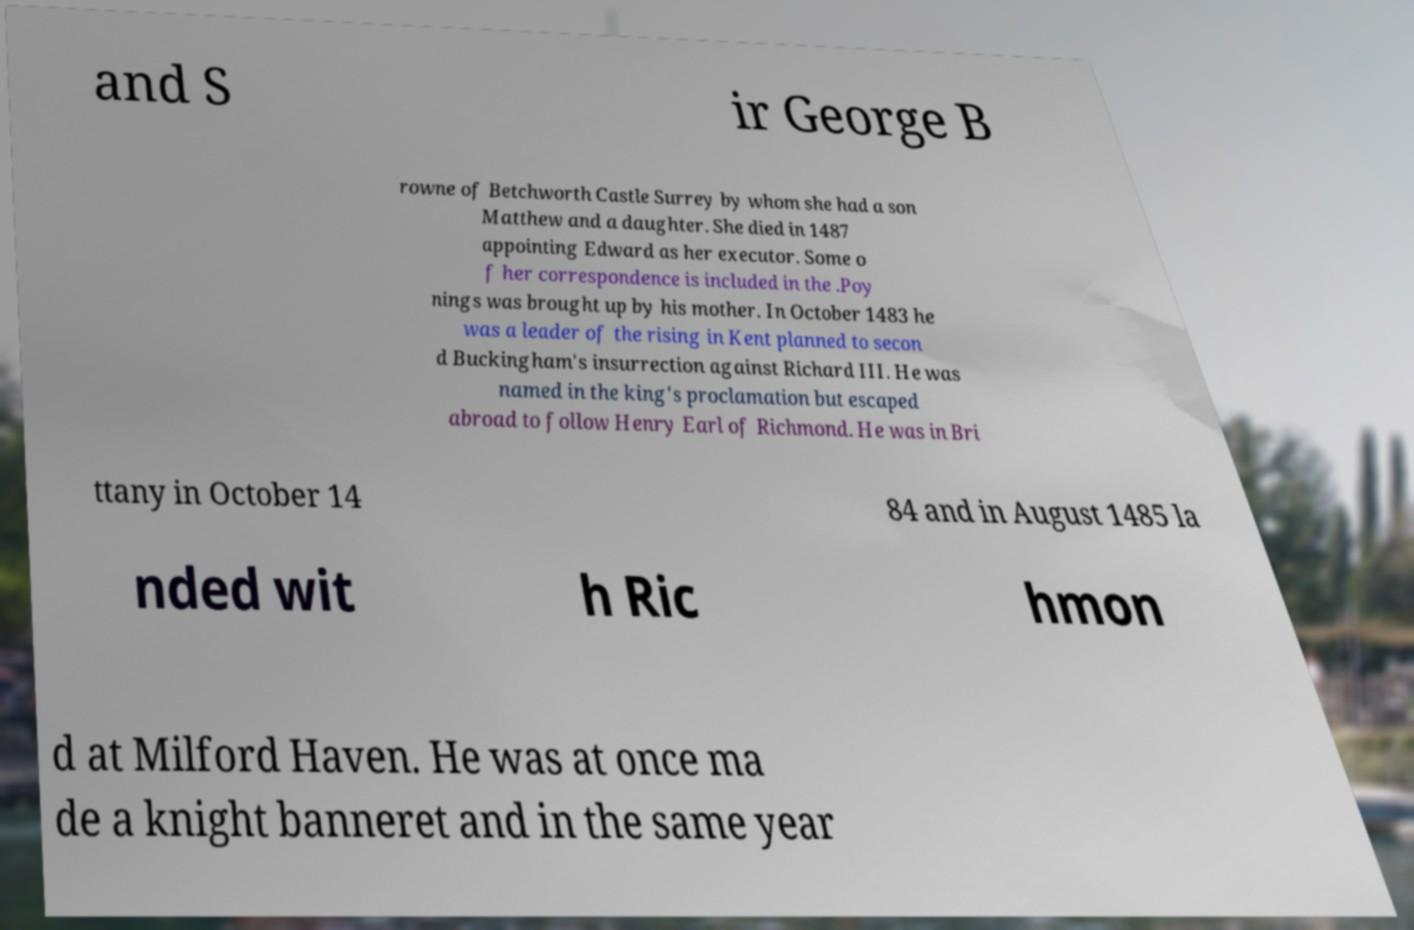For documentation purposes, I need the text within this image transcribed. Could you provide that? and S ir George B rowne of Betchworth Castle Surrey by whom she had a son Matthew and a daughter. She died in 1487 appointing Edward as her executor. Some o f her correspondence is included in the .Poy nings was brought up by his mother. In October 1483 he was a leader of the rising in Kent planned to secon d Buckingham's insurrection against Richard III. He was named in the king's proclamation but escaped abroad to follow Henry Earl of Richmond. He was in Bri ttany in October 14 84 and in August 1485 la nded wit h Ric hmon d at Milford Haven. He was at once ma de a knight banneret and in the same year 